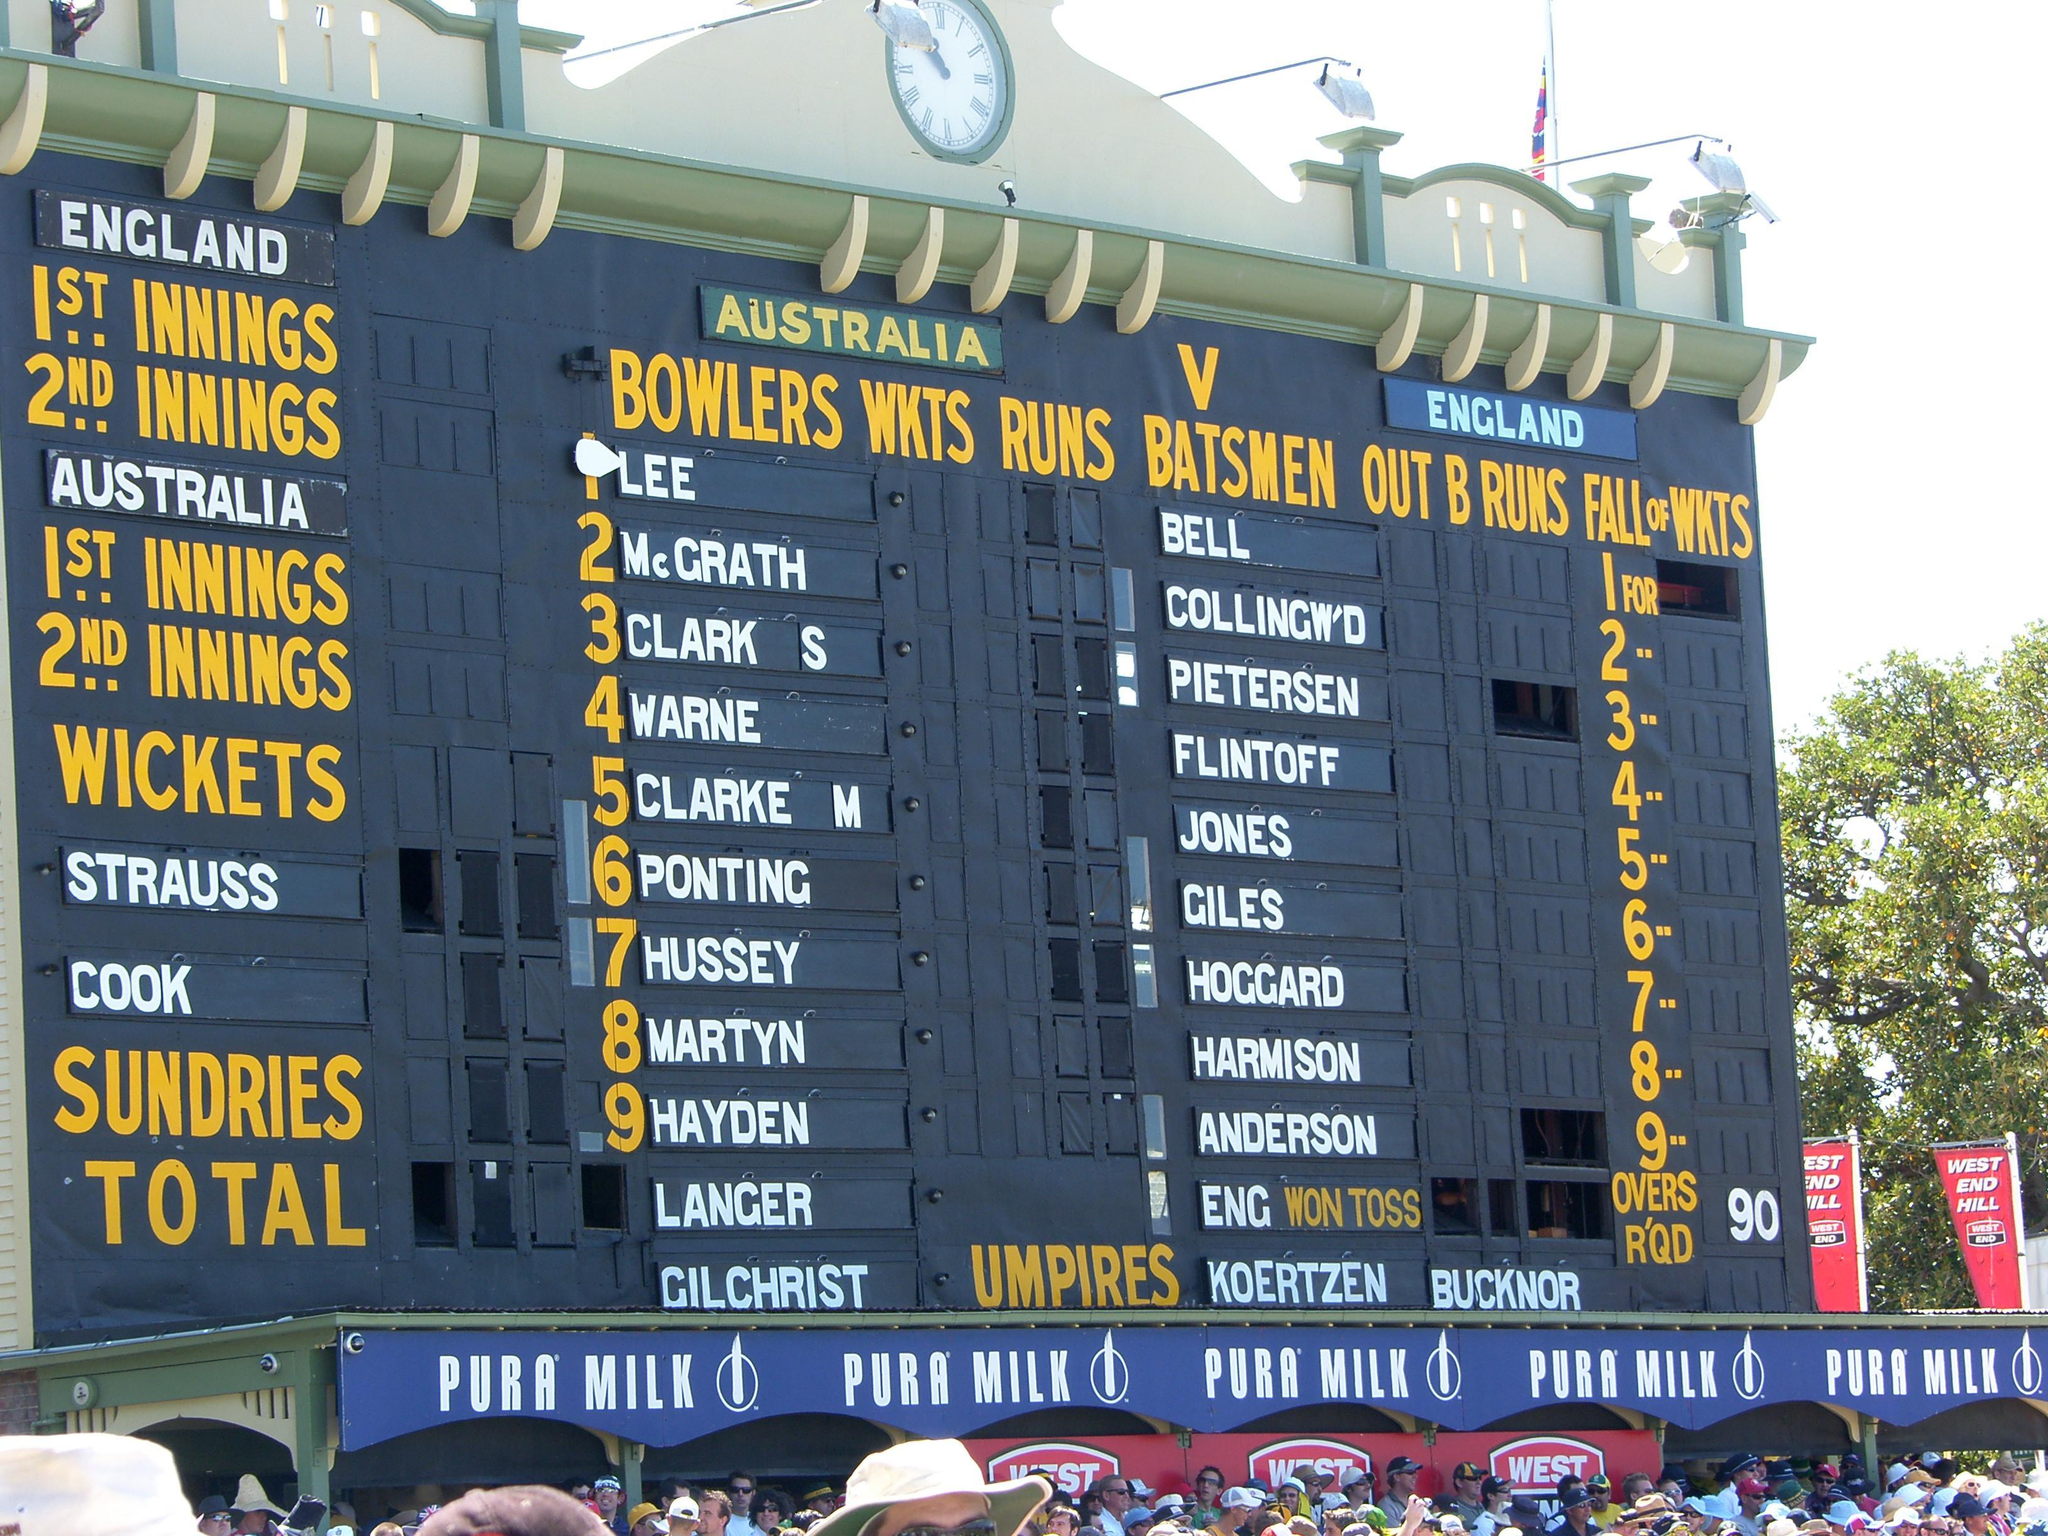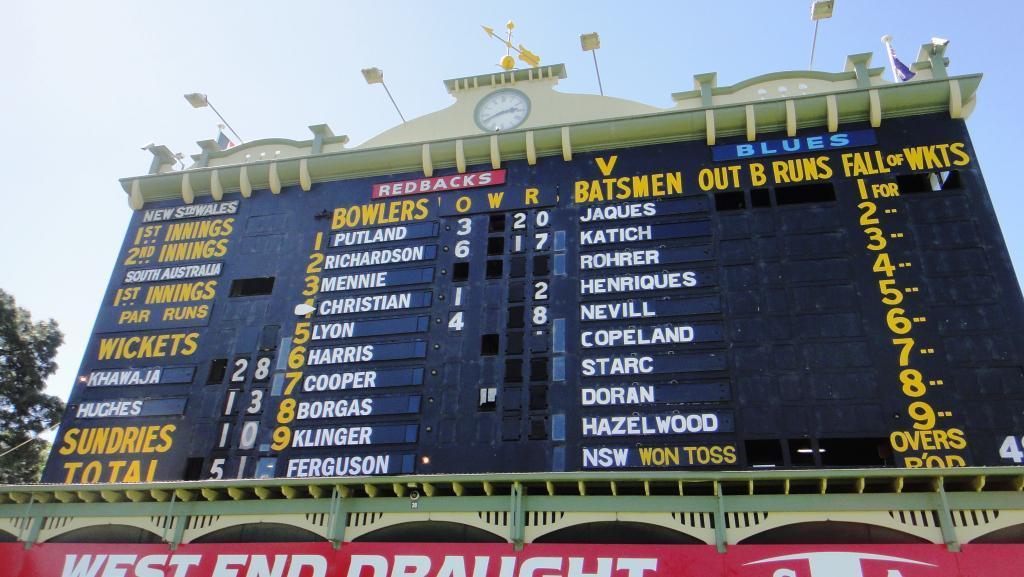The first image is the image on the left, the second image is the image on the right. Given the left and right images, does the statement "A blue advertisement sits beneath the scoreboard in the image on the left." hold true? Answer yes or no. Yes. The first image is the image on the left, the second image is the image on the right. Analyze the images presented: Is the assertion "Each image features a scoreboard with a clock centered above it, and one image shows a horizontal blue banner hanging under and in front of the scoreboard." valid? Answer yes or no. Yes. 